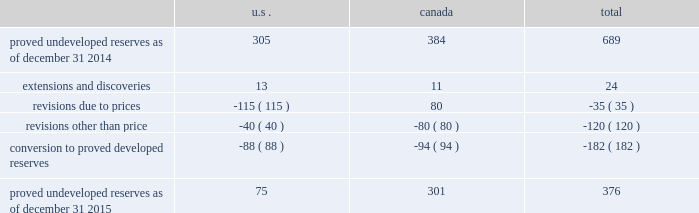Devon energy corporation and subsidiaries notes to consolidated financial statements 2013 ( continued ) proved undeveloped reserves the table presents the changes in devon 2019s total proved undeveloped reserves during 2015 ( mmboe ) . .
Proved undeveloped reserves decreased 45% ( 45 % ) from year-end 2014 to year-end 2015 , and the year-end 2015 balance represents 17% ( 17 % ) of total proved reserves .
Drilling and development activities increased devon 2019s proved undeveloped reserves 24 mmboe and resulted in the conversion of 182 mmboe , or 26% ( 26 % ) , of the 2014 proved undeveloped reserves to proved developed reserves .
Costs incurred to develop and convert devon 2019s proved undeveloped reserves were approximately $ 2.2 billion for 2015 .
Additionally , revisions other than price decreased devon 2019s proved undeveloped reserves 120 mmboe primarily due to evaluations of certain properties in the u.s .
And canada .
The largest revisions , which reduced reserves by 80 mmboe , relate to evaluations of jackfish bitumen reserves .
Of the 40 mmboe revisions recorded for u.s .
Properties , a reduction of approximately 27 mmboe represents reserves that devon now does not expect to develop in the next five years , including 20 mmboe attributable to the eagle ford .
A significant amount of devon 2019s proved undeveloped reserves at the end of 2015 related to its jackfish operations .
At december 31 , 2015 and 2014 , devon 2019s jackfish proved undeveloped reserves were 301 mmboe and 384 mmboe , respectively .
Development schedules for the jackfish reserves are primarily controlled by the need to keep the processing plants at their 35 mbbl daily facility capacity .
Processing plant capacity is controlled by factors such as total steam processing capacity and steam-oil ratios .
Furthermore , development of these projects involves the up-front construction of steam injection/distribution and bitumen processing facilities .
Due to the large up-front capital investments and large reserves required to provide economic returns , the project conditions meet the specific circumstances requiring a period greater than 5 years for conversion to developed reserves .
As a result , these reserves are classified as proved undeveloped for more than five years .
Currently , the development schedule for these reserves extends through to 2030 .
At the end of 2015 , approximately 184 mmboe of proved undeveloped reserves at jackfish have remained undeveloped for five years or more since the initial booking .
No other projects have proved undeveloped reserves that have remained undeveloped more than five years from the initial booking of the reserves .
Furthermore , approximately 180 mmboe of proved undeveloped reserves at jackfish will require in excess of five years , from the date of this filing , to develop .
Price revisions 2015 2013 reserves decreased 302 mmboe primarily due to lower commodity prices across all products .
The lower bitumen price increased canadian reserves due to the decline in royalties , which increases devon 2019s after- royalty volumes .
2014 2013 reserves increased 9 mmboe primarily due to higher gas prices in the barnett shale and the anadarko basin , partially offset by higher bitumen prices , which result in lower after-royalty volumes , in canada. .
What was the total number , in mmboe , of 2014 proved developed reserves? 
Computations: (182 * (100 / 26))
Answer: 700.0. 